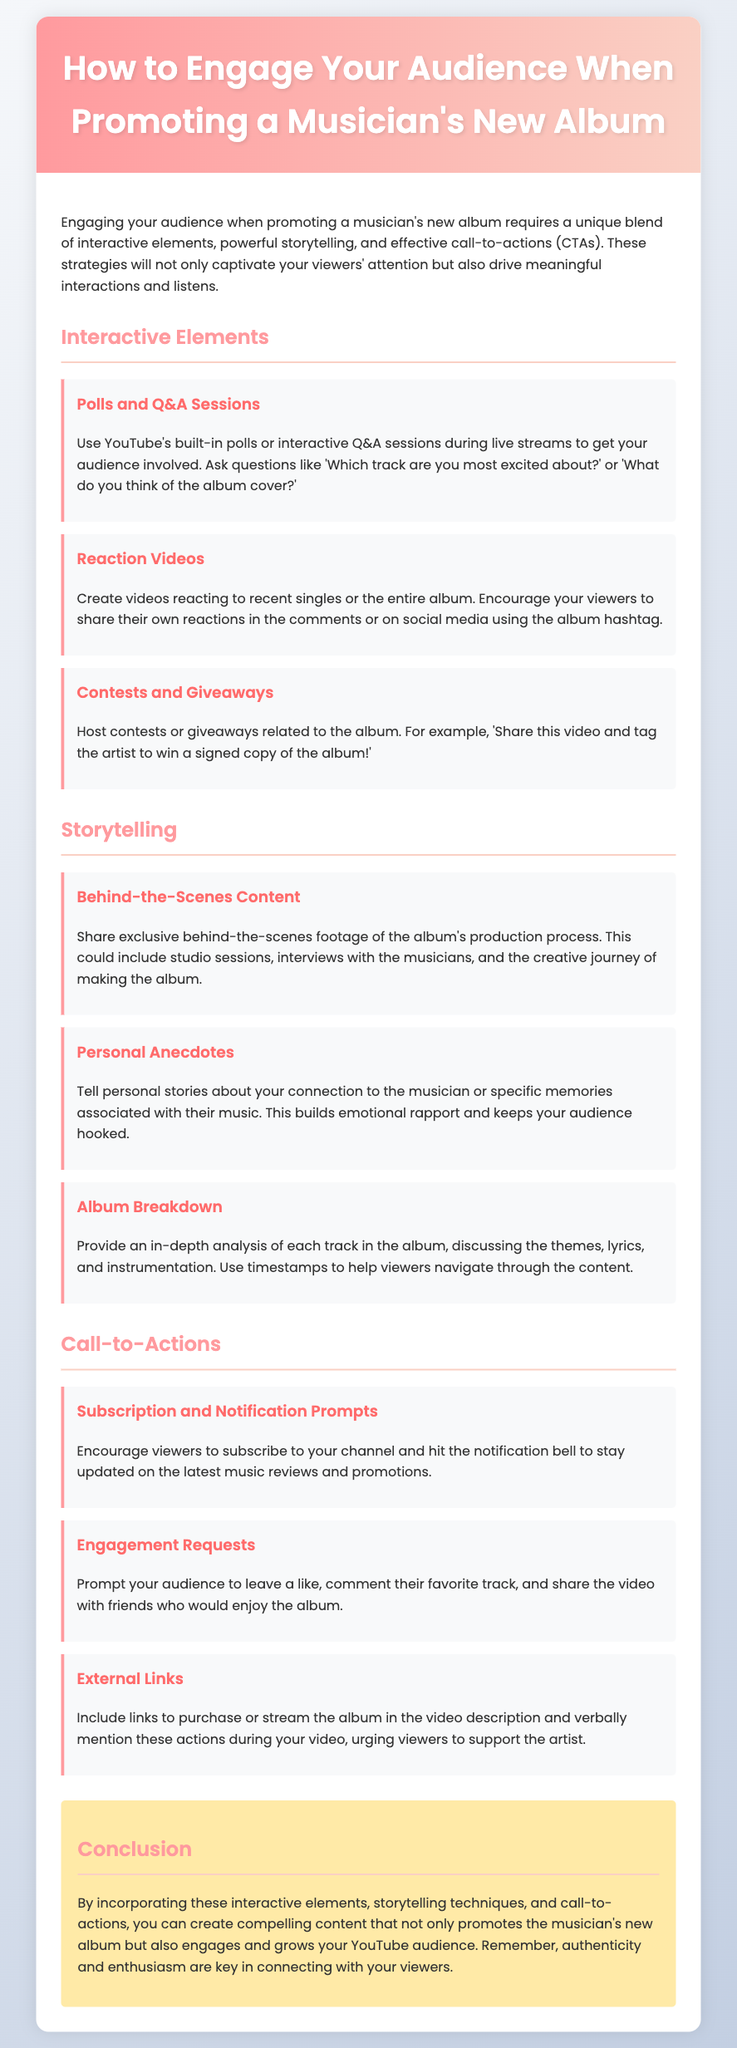What are three interactive elements mentioned? The document lists "Polls and Q&A Sessions," "Reaction Videos," and "Contests and Giveaways" as interactive elements.
Answer: Polls and Q&A Sessions, Reaction Videos, Contests and Giveaways What section discusses personal stories? The section on "Storytelling" includes the element "Personal Anecdotes," which covers sharing personal stories.
Answer: Storytelling How many types of call-to-actions are listed? The document mentions three types of call-to-actions: "Subscription and Notification Prompts," "Engagement Requests," and "External Links."
Answer: Three What technique is suggested for album promotion? The document suggests sharing "Behind-the-Scenes Content" as a technique for engaging the audience.
Answer: Behind-the-Scenes Content What is the main goal of using interactive elements in promotion? The primary goal is to "captivate your viewers' attention" and drive interactions and listens.
Answer: Captivate viewers' attention 